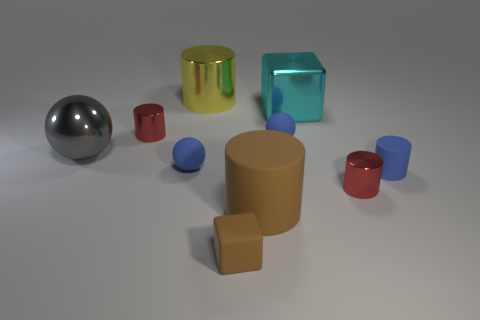Is there a large gray shiny thing that has the same shape as the large brown object?
Your answer should be compact. No. What number of other big objects have the same shape as the yellow thing?
Keep it short and to the point. 1. There is a cube that is in front of the metal block; does it have the same size as the ball behind the large gray sphere?
Your answer should be compact. Yes. There is a big metal object in front of the big cyan thing that is behind the brown block; what shape is it?
Provide a succinct answer. Sphere. Are there the same number of brown cylinders that are right of the big cyan metallic object and gray cylinders?
Make the answer very short. Yes. What material is the red cylinder in front of the small rubber object that is on the right side of the red thing that is in front of the large gray thing made of?
Offer a terse response. Metal. Is there a gray shiny sphere of the same size as the cyan shiny object?
Provide a succinct answer. Yes. What is the shape of the big gray object?
Offer a very short reply. Sphere. What number of cylinders are big things or large gray objects?
Make the answer very short. 2. Are there an equal number of metal cylinders that are behind the large gray metal sphere and brown matte cylinders behind the big brown rubber object?
Your response must be concise. No. 